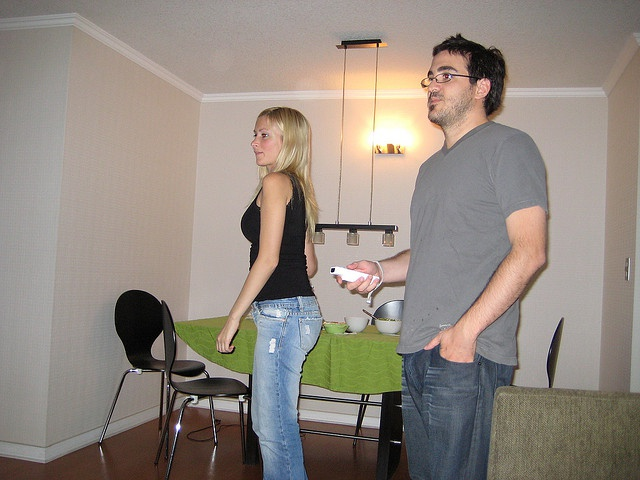Describe the objects in this image and their specific colors. I can see people in gray, tan, and black tones, people in gray, black, darkgray, and tan tones, dining table in gray and olive tones, chair in gray, black, and darkgray tones, and chair in gray, black, and darkgray tones in this image. 